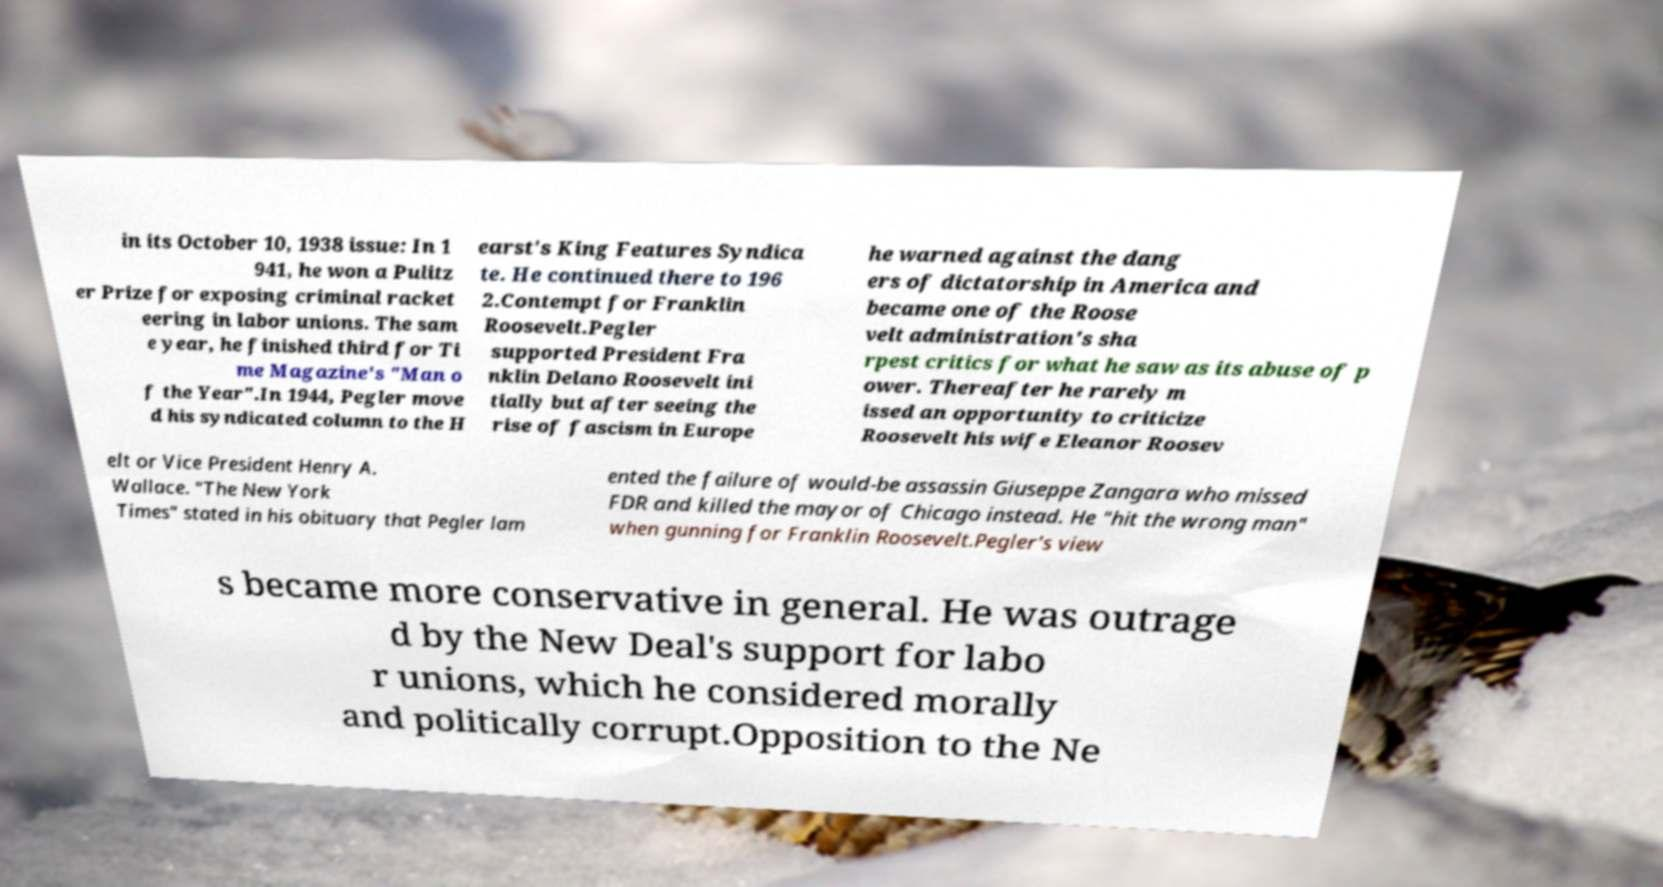What messages or text are displayed in this image? I need them in a readable, typed format. in its October 10, 1938 issue: In 1 941, he won a Pulitz er Prize for exposing criminal racket eering in labor unions. The sam e year, he finished third for Ti me Magazine's "Man o f the Year".In 1944, Pegler move d his syndicated column to the H earst's King Features Syndica te. He continued there to 196 2.Contempt for Franklin Roosevelt.Pegler supported President Fra nklin Delano Roosevelt ini tially but after seeing the rise of fascism in Europe he warned against the dang ers of dictatorship in America and became one of the Roose velt administration's sha rpest critics for what he saw as its abuse of p ower. Thereafter he rarely m issed an opportunity to criticize Roosevelt his wife Eleanor Roosev elt or Vice President Henry A. Wallace. "The New York Times" stated in his obituary that Pegler lam ented the failure of would-be assassin Giuseppe Zangara who missed FDR and killed the mayor of Chicago instead. He "hit the wrong man" when gunning for Franklin Roosevelt.Pegler's view s became more conservative in general. He was outrage d by the New Deal's support for labo r unions, which he considered morally and politically corrupt.Opposition to the Ne 